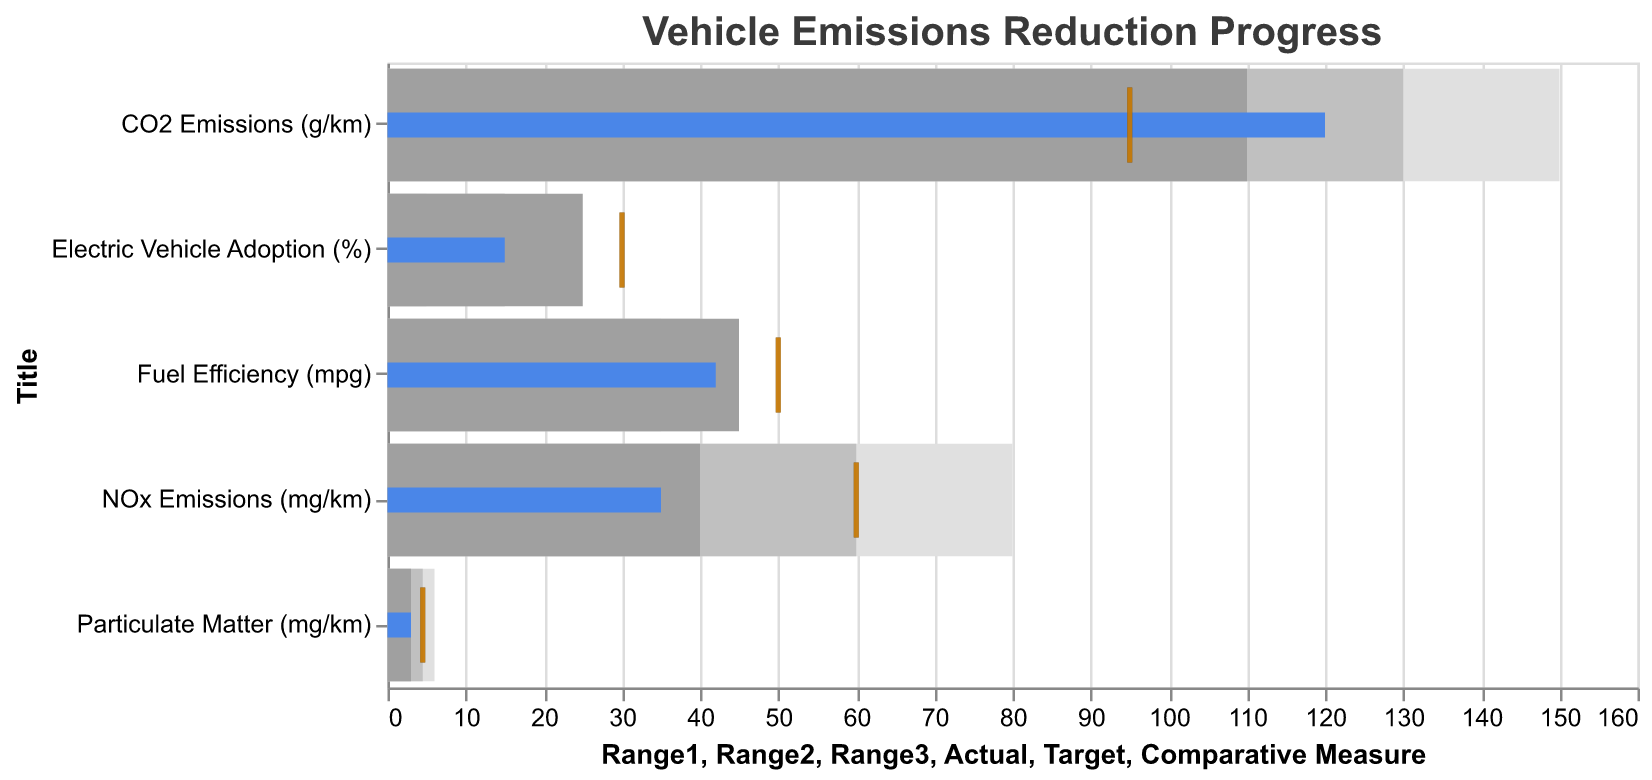How many different environmental metrics are shown in the bullet chart? The bullet chart displays one metric per bar, and each bar is labeled with a different title, such as "CO2 Emissions", "NOx Emissions", "Particulate Matter", "Fuel Efficiency", and "Electric Vehicle Adoption". Count the number of unique titles.
Answer: 5 What is the target value for CO2 Emissions? Refer to the indicated target tick marks for each metric. There is a tick mark in black labelled "CO2 Emissions (g/km)" at the x-axis value of 95.
Answer: 95 Is the actual NOx Emissions value better or worse than the target? Compare the actual value bar to the target tick mark. The actual value (blue bar) for "NOx Emissions (mg/km)" is at 35, which is lower than the target tick mark at 60, indicating better performance.
Answer: Better By how much does the actual Fuel Efficiency fall short of the target? Find the actual value and the target value for "Fuel Efficiency (mpg)". The actual value is 42, and the target value is 50. Subtract the actual value from the target value (50 - 42).
Answer: 8 Does Particulate Matter meet or exceed the target? Look at the actual value bar (blue) and the target tick mark for "Particulate Matter (mg/km)". The actual value is 3, which is lower than the target value of 4.5.
Answer: Exceed Which environmental metric is closest to meeting its target? Compare the differences between actual values and target values visually. "Particulate Matter" has its actual value (3) closest to the target (4.5).
Answer: Particulate Matter How far is Electric Vehicle Adoption from the comparative measure? Compare the actual percentage given (15%) with the comparative measure (30%). Calculate the difference (30 - 15).
Answer: 15% What is the range considered "good" for NOx Emissions? The range bars display this information shaded from light to dark grey. For "NOx Emissions (mg/km)", the darkest grey bar (good range) represents 40 mg/km.
Answer: 40 mg/km Which metric shows the largest disparity between actual value and target value? Calculate the absolute difference between actual values and target values for each metric. "Electric Vehicle Adoption" has the largest difference. The target is 30% and the actual is 15%. Absolute difference is 15.
Answer: Electric Vehicle Adoption Is the actual CO2 Emissions value within any acceptable range? Locate the actual value and see if it falls within any shaded grey range bars. The actual value for "CO2 Emissions (g/km)" is 120, which falls within the lightest grey range of up to 150.
Answer: Yes 